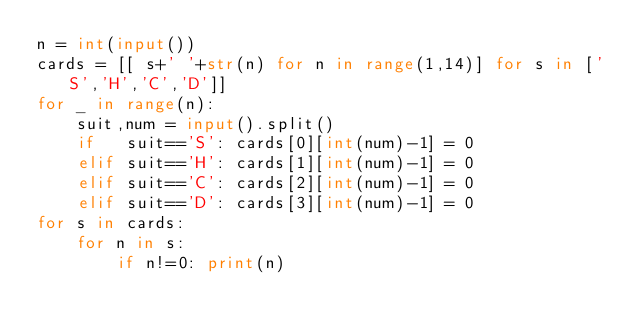<code> <loc_0><loc_0><loc_500><loc_500><_Python_>n = int(input())
cards = [[ s+' '+str(n) for n in range(1,14)] for s in ['S','H','C','D']]
for _ in range(n):
    suit,num = input().split()
    if   suit=='S': cards[0][int(num)-1] = 0
    elif suit=='H': cards[1][int(num)-1] = 0
    elif suit=='C': cards[2][int(num)-1] = 0
    elif suit=='D': cards[3][int(num)-1] = 0
for s in cards:
    for n in s:
        if n!=0: print(n)
</code> 